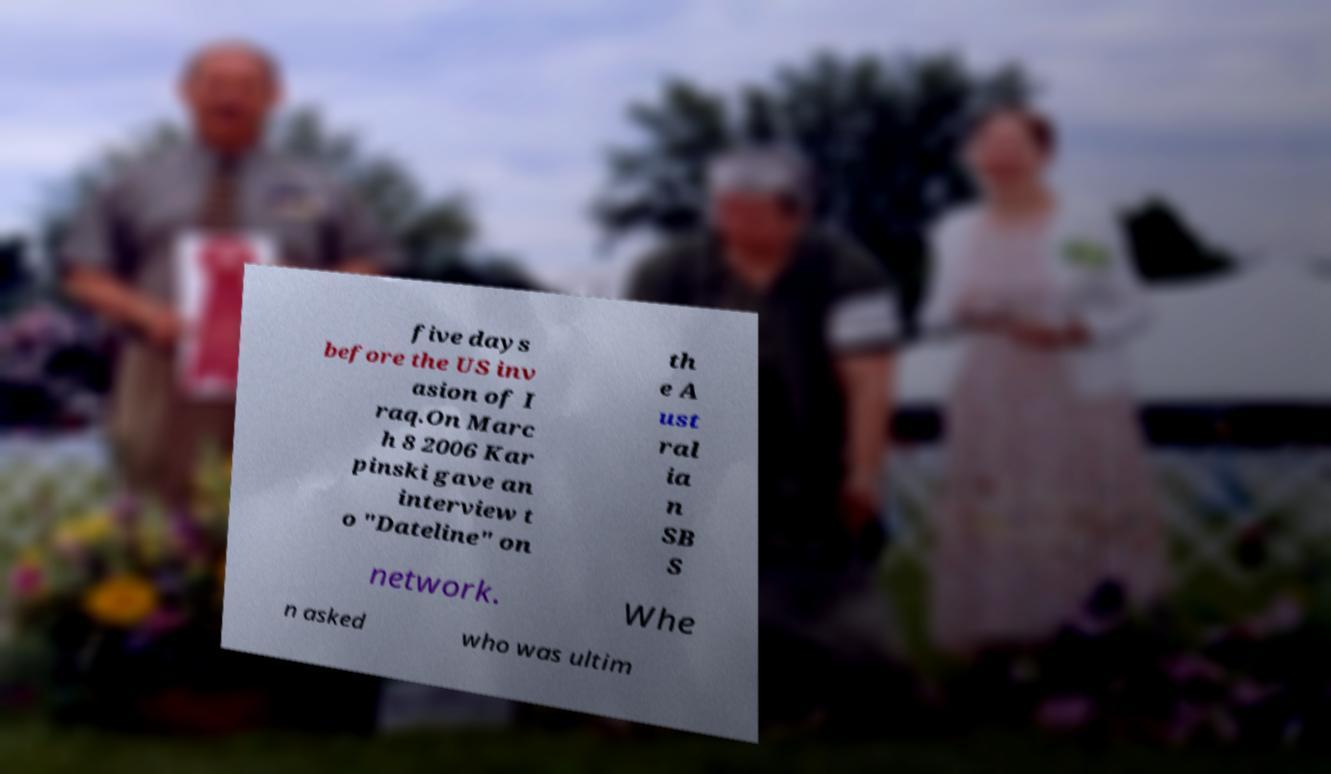Could you assist in decoding the text presented in this image and type it out clearly? five days before the US inv asion of I raq.On Marc h 8 2006 Kar pinski gave an interview t o "Dateline" on th e A ust ral ia n SB S network. Whe n asked who was ultim 